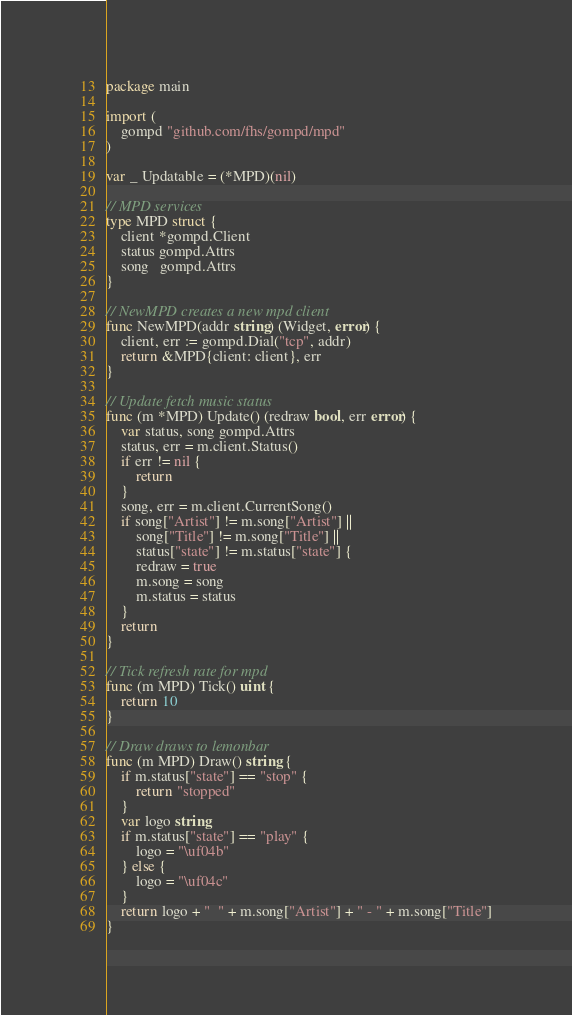Convert code to text. <code><loc_0><loc_0><loc_500><loc_500><_Go_>package main

import (
	gompd "github.com/fhs/gompd/mpd"
)

var _ Updatable = (*MPD)(nil)

// MPD services
type MPD struct {
	client *gompd.Client
	status gompd.Attrs
	song   gompd.Attrs
}

// NewMPD creates a new mpd client
func NewMPD(addr string) (Widget, error) {
	client, err := gompd.Dial("tcp", addr)
	return &MPD{client: client}, err
}

// Update fetch music status
func (m *MPD) Update() (redraw bool, err error) {
	var status, song gompd.Attrs
	status, err = m.client.Status()
	if err != nil {
		return
	}
	song, err = m.client.CurrentSong()
	if song["Artist"] != m.song["Artist"] ||
		song["Title"] != m.song["Title"] ||
		status["state"] != m.status["state"] {
		redraw = true
		m.song = song
		m.status = status
	}
	return
}

// Tick refresh rate for mpd
func (m MPD) Tick() uint {
	return 10
}

// Draw draws to lemonbar
func (m MPD) Draw() string {
	if m.status["state"] == "stop" {
		return "stopped"
	}
	var logo string
	if m.status["state"] == "play" {
		logo = "\uf04b"
	} else {
		logo = "\uf04c"
	}
	return logo + "  " + m.song["Artist"] + " - " + m.song["Title"]
}
</code> 